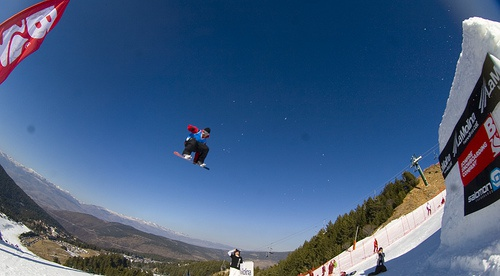Describe the objects in this image and their specific colors. I can see people in gray, black, blue, and navy tones, people in gray, black, white, and darkgray tones, people in gray, black, navy, and blue tones, people in gray, lightgray, brown, and lightpink tones, and snowboard in gray, salmon, and black tones in this image. 